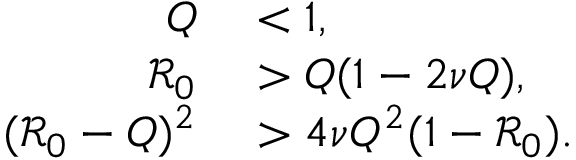Convert formula to latex. <formula><loc_0><loc_0><loc_500><loc_500>\begin{array} { r l } { Q } & < 1 , } \\ { \mathcal { R } _ { 0 } } & > Q ( 1 - 2 \nu Q ) , } \\ { ( \mathcal { R } _ { 0 } - Q ) ^ { 2 } } & > 4 \nu Q ^ { 2 } ( 1 - \mathcal { R } _ { 0 } ) . } \end{array}</formula> 